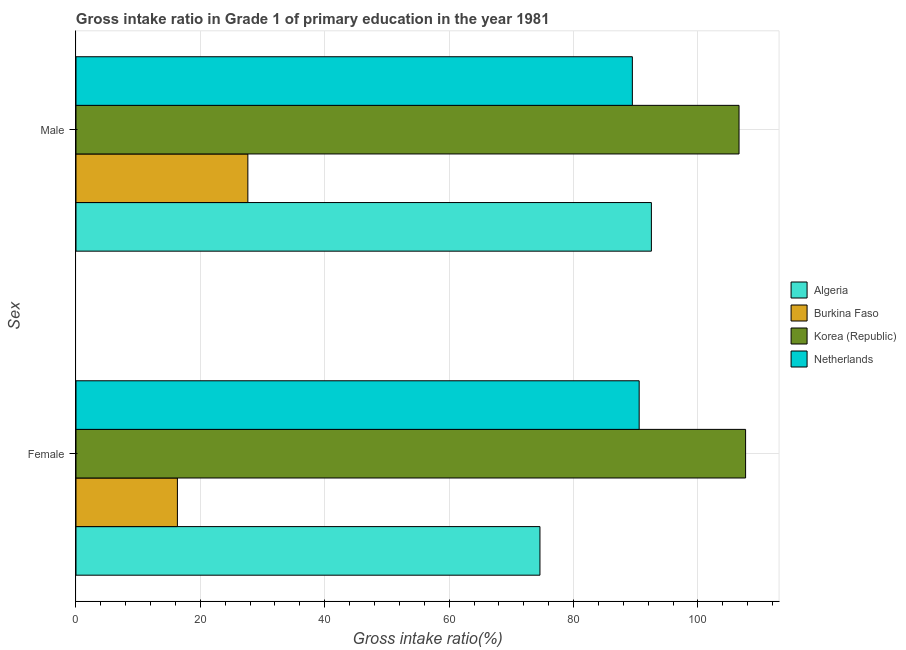Are the number of bars on each tick of the Y-axis equal?
Your response must be concise. Yes. How many bars are there on the 1st tick from the bottom?
Provide a short and direct response. 4. What is the gross intake ratio(male) in Netherlands?
Provide a succinct answer. 89.47. Across all countries, what is the maximum gross intake ratio(female)?
Keep it short and to the point. 107.67. Across all countries, what is the minimum gross intake ratio(male)?
Give a very brief answer. 27.64. In which country was the gross intake ratio(female) maximum?
Provide a succinct answer. Korea (Republic). In which country was the gross intake ratio(female) minimum?
Provide a succinct answer. Burkina Faso. What is the total gross intake ratio(male) in the graph?
Your answer should be very brief. 316.25. What is the difference between the gross intake ratio(female) in Netherlands and that in Algeria?
Provide a short and direct response. 15.95. What is the difference between the gross intake ratio(male) in Korea (Republic) and the gross intake ratio(female) in Burkina Faso?
Provide a short and direct response. 90.31. What is the average gross intake ratio(male) per country?
Offer a terse response. 79.06. What is the difference between the gross intake ratio(male) and gross intake ratio(female) in Algeria?
Offer a very short reply. 17.92. In how many countries, is the gross intake ratio(male) greater than 84 %?
Give a very brief answer. 3. What is the ratio of the gross intake ratio(male) in Korea (Republic) to that in Netherlands?
Make the answer very short. 1.19. Is the gross intake ratio(male) in Korea (Republic) less than that in Netherlands?
Your answer should be compact. No. What does the 1st bar from the top in Female represents?
Your answer should be compact. Netherlands. What does the 2nd bar from the bottom in Male represents?
Offer a very short reply. Burkina Faso. What is the difference between two consecutive major ticks on the X-axis?
Keep it short and to the point. 20. Does the graph contain grids?
Provide a short and direct response. Yes. Where does the legend appear in the graph?
Your answer should be very brief. Center right. How many legend labels are there?
Your answer should be compact. 4. What is the title of the graph?
Offer a very short reply. Gross intake ratio in Grade 1 of primary education in the year 1981. Does "United States" appear as one of the legend labels in the graph?
Keep it short and to the point. No. What is the label or title of the X-axis?
Give a very brief answer. Gross intake ratio(%). What is the label or title of the Y-axis?
Keep it short and to the point. Sex. What is the Gross intake ratio(%) in Algeria in Female?
Your answer should be very brief. 74.61. What is the Gross intake ratio(%) in Burkina Faso in Female?
Provide a short and direct response. 16.31. What is the Gross intake ratio(%) in Korea (Republic) in Female?
Ensure brevity in your answer.  107.67. What is the Gross intake ratio(%) in Netherlands in Female?
Provide a short and direct response. 90.56. What is the Gross intake ratio(%) of Algeria in Male?
Give a very brief answer. 92.53. What is the Gross intake ratio(%) of Burkina Faso in Male?
Provide a short and direct response. 27.64. What is the Gross intake ratio(%) in Korea (Republic) in Male?
Your response must be concise. 106.62. What is the Gross intake ratio(%) of Netherlands in Male?
Provide a short and direct response. 89.47. Across all Sex, what is the maximum Gross intake ratio(%) in Algeria?
Offer a very short reply. 92.53. Across all Sex, what is the maximum Gross intake ratio(%) of Burkina Faso?
Give a very brief answer. 27.64. Across all Sex, what is the maximum Gross intake ratio(%) of Korea (Republic)?
Your answer should be very brief. 107.67. Across all Sex, what is the maximum Gross intake ratio(%) of Netherlands?
Your response must be concise. 90.56. Across all Sex, what is the minimum Gross intake ratio(%) in Algeria?
Offer a very short reply. 74.61. Across all Sex, what is the minimum Gross intake ratio(%) of Burkina Faso?
Your answer should be very brief. 16.31. Across all Sex, what is the minimum Gross intake ratio(%) of Korea (Republic)?
Give a very brief answer. 106.62. Across all Sex, what is the minimum Gross intake ratio(%) of Netherlands?
Give a very brief answer. 89.47. What is the total Gross intake ratio(%) in Algeria in the graph?
Give a very brief answer. 167.13. What is the total Gross intake ratio(%) in Burkina Faso in the graph?
Your answer should be very brief. 43.95. What is the total Gross intake ratio(%) of Korea (Republic) in the graph?
Keep it short and to the point. 214.29. What is the total Gross intake ratio(%) in Netherlands in the graph?
Give a very brief answer. 180.03. What is the difference between the Gross intake ratio(%) of Algeria in Female and that in Male?
Give a very brief answer. -17.92. What is the difference between the Gross intake ratio(%) in Burkina Faso in Female and that in Male?
Provide a short and direct response. -11.33. What is the difference between the Gross intake ratio(%) in Korea (Republic) in Female and that in Male?
Your response must be concise. 1.05. What is the difference between the Gross intake ratio(%) of Netherlands in Female and that in Male?
Your answer should be very brief. 1.09. What is the difference between the Gross intake ratio(%) of Algeria in Female and the Gross intake ratio(%) of Burkina Faso in Male?
Your response must be concise. 46.97. What is the difference between the Gross intake ratio(%) in Algeria in Female and the Gross intake ratio(%) in Korea (Republic) in Male?
Provide a short and direct response. -32.01. What is the difference between the Gross intake ratio(%) of Algeria in Female and the Gross intake ratio(%) of Netherlands in Male?
Make the answer very short. -14.86. What is the difference between the Gross intake ratio(%) of Burkina Faso in Female and the Gross intake ratio(%) of Korea (Republic) in Male?
Ensure brevity in your answer.  -90.31. What is the difference between the Gross intake ratio(%) of Burkina Faso in Female and the Gross intake ratio(%) of Netherlands in Male?
Your answer should be compact. -73.16. What is the difference between the Gross intake ratio(%) of Korea (Republic) in Female and the Gross intake ratio(%) of Netherlands in Male?
Provide a short and direct response. 18.21. What is the average Gross intake ratio(%) of Algeria per Sex?
Provide a succinct answer. 83.57. What is the average Gross intake ratio(%) in Burkina Faso per Sex?
Your answer should be very brief. 21.97. What is the average Gross intake ratio(%) of Korea (Republic) per Sex?
Make the answer very short. 107.15. What is the average Gross intake ratio(%) of Netherlands per Sex?
Your response must be concise. 90.01. What is the difference between the Gross intake ratio(%) of Algeria and Gross intake ratio(%) of Burkina Faso in Female?
Your answer should be compact. 58.3. What is the difference between the Gross intake ratio(%) in Algeria and Gross intake ratio(%) in Korea (Republic) in Female?
Your answer should be compact. -33.07. What is the difference between the Gross intake ratio(%) in Algeria and Gross intake ratio(%) in Netherlands in Female?
Offer a very short reply. -15.95. What is the difference between the Gross intake ratio(%) of Burkina Faso and Gross intake ratio(%) of Korea (Republic) in Female?
Your answer should be compact. -91.37. What is the difference between the Gross intake ratio(%) in Burkina Faso and Gross intake ratio(%) in Netherlands in Female?
Provide a succinct answer. -74.25. What is the difference between the Gross intake ratio(%) of Korea (Republic) and Gross intake ratio(%) of Netherlands in Female?
Your answer should be very brief. 17.11. What is the difference between the Gross intake ratio(%) in Algeria and Gross intake ratio(%) in Burkina Faso in Male?
Offer a very short reply. 64.89. What is the difference between the Gross intake ratio(%) in Algeria and Gross intake ratio(%) in Korea (Republic) in Male?
Provide a short and direct response. -14.09. What is the difference between the Gross intake ratio(%) of Algeria and Gross intake ratio(%) of Netherlands in Male?
Your answer should be compact. 3.06. What is the difference between the Gross intake ratio(%) of Burkina Faso and Gross intake ratio(%) of Korea (Republic) in Male?
Ensure brevity in your answer.  -78.98. What is the difference between the Gross intake ratio(%) of Burkina Faso and Gross intake ratio(%) of Netherlands in Male?
Offer a very short reply. -61.83. What is the difference between the Gross intake ratio(%) of Korea (Republic) and Gross intake ratio(%) of Netherlands in Male?
Provide a succinct answer. 17.15. What is the ratio of the Gross intake ratio(%) in Algeria in Female to that in Male?
Your response must be concise. 0.81. What is the ratio of the Gross intake ratio(%) of Burkina Faso in Female to that in Male?
Offer a terse response. 0.59. What is the ratio of the Gross intake ratio(%) in Korea (Republic) in Female to that in Male?
Offer a very short reply. 1.01. What is the ratio of the Gross intake ratio(%) of Netherlands in Female to that in Male?
Ensure brevity in your answer.  1.01. What is the difference between the highest and the second highest Gross intake ratio(%) of Algeria?
Your answer should be very brief. 17.92. What is the difference between the highest and the second highest Gross intake ratio(%) in Burkina Faso?
Your answer should be very brief. 11.33. What is the difference between the highest and the second highest Gross intake ratio(%) in Korea (Republic)?
Your response must be concise. 1.05. What is the difference between the highest and the second highest Gross intake ratio(%) in Netherlands?
Offer a terse response. 1.09. What is the difference between the highest and the lowest Gross intake ratio(%) of Algeria?
Ensure brevity in your answer.  17.92. What is the difference between the highest and the lowest Gross intake ratio(%) of Burkina Faso?
Provide a short and direct response. 11.33. What is the difference between the highest and the lowest Gross intake ratio(%) in Korea (Republic)?
Give a very brief answer. 1.05. What is the difference between the highest and the lowest Gross intake ratio(%) of Netherlands?
Offer a very short reply. 1.09. 